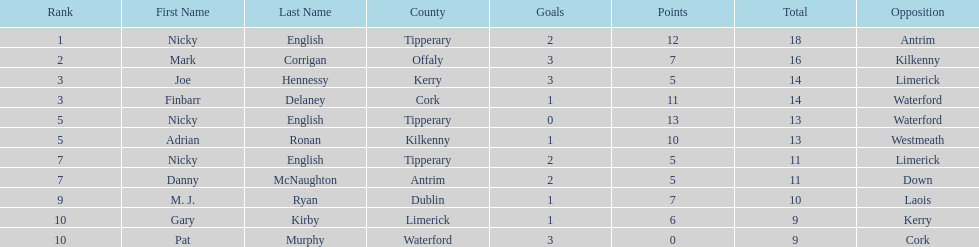If you added all the total's up, what would the number be? 138. 